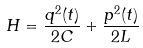<formula> <loc_0><loc_0><loc_500><loc_500>H = \frac { q ^ { 2 } ( t ) } { 2 C } + \frac { p ^ { 2 } ( t ) } { 2 L }</formula> 